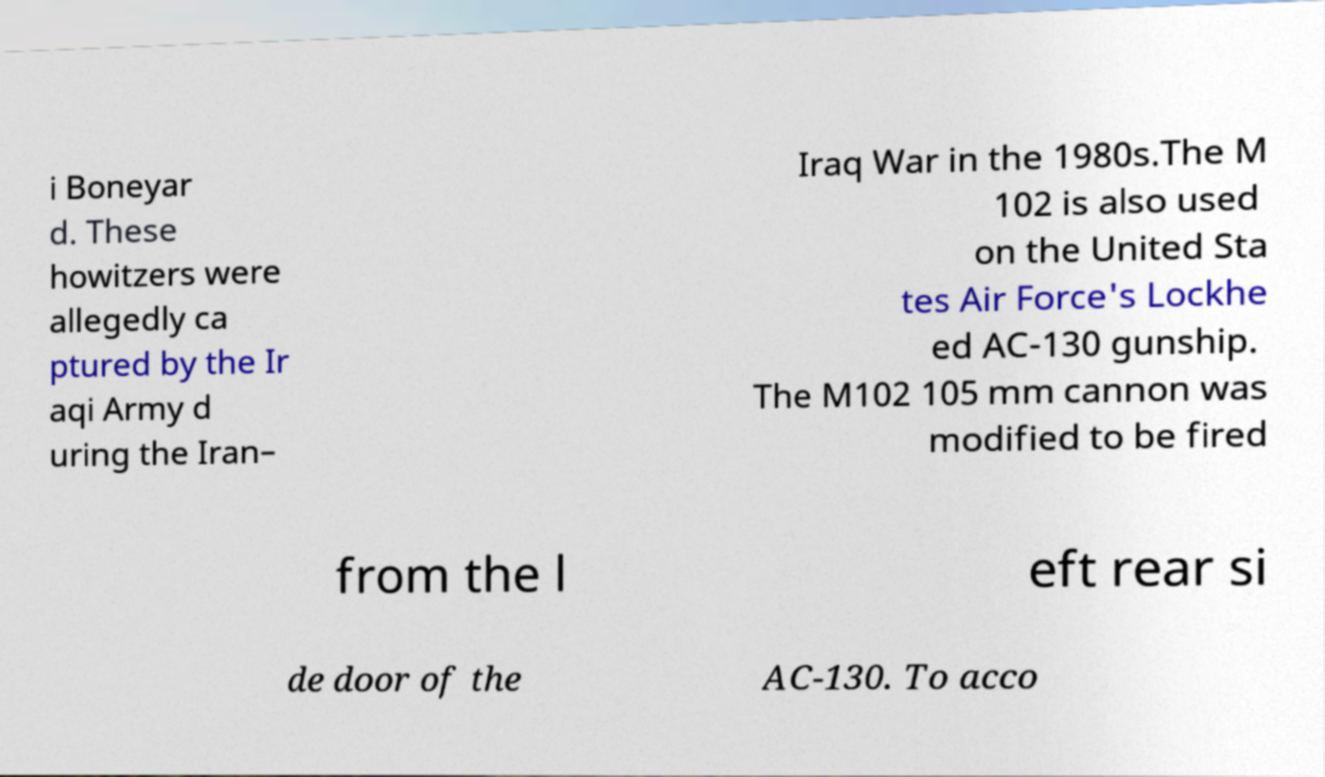Please read and relay the text visible in this image. What does it say? i Boneyar d. These howitzers were allegedly ca ptured by the Ir aqi Army d uring the Iran– Iraq War in the 1980s.The M 102 is also used on the United Sta tes Air Force's Lockhe ed AC-130 gunship. The M102 105 mm cannon was modified to be fired from the l eft rear si de door of the AC-130. To acco 